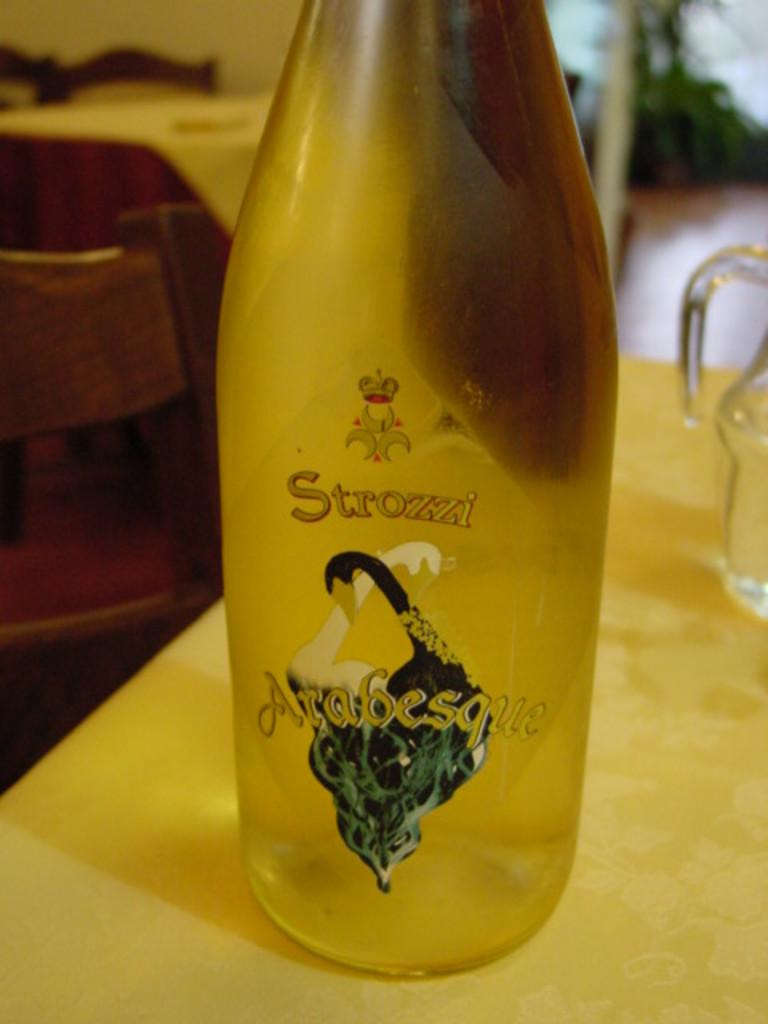What object is visible in the image that is typically used for holding liquids? There is a bottle in the image, which is typically used for holding liquids. Where is the bottle located in the image? The bottle is placed on a table in the image. What other object, similar to the bottle, can be seen in the image? There is a mug in the image, which is also typically used for holding liquids. Where is the mug located in the image? The mug is placed on a table in the image. What can be seen in the background of the image? There are chairs in the background of the image. What type of brush is being used to paint the rod in the image? There is no brush or rod present in the image; it features a bottle and a mug placed on a table. 